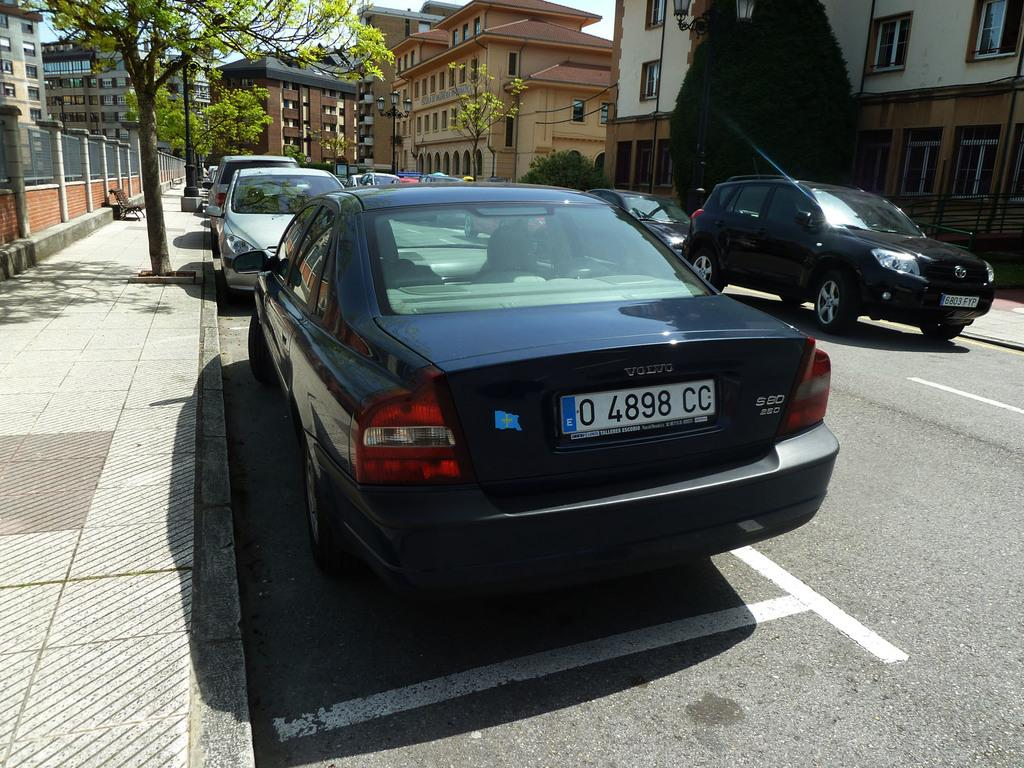Provide a one-sentence caption for the provided image. A black Volvo sits in a parking spot alongside the curb. 